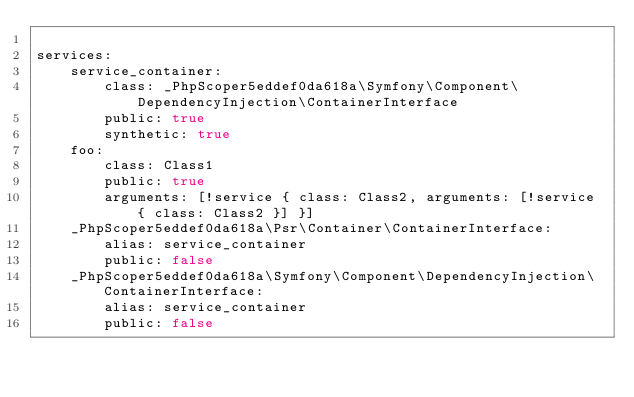Convert code to text. <code><loc_0><loc_0><loc_500><loc_500><_YAML_>
services:
    service_container:
        class: _PhpScoper5eddef0da618a\Symfony\Component\DependencyInjection\ContainerInterface
        public: true
        synthetic: true
    foo:
        class: Class1
        public: true
        arguments: [!service { class: Class2, arguments: [!service { class: Class2 }] }]
    _PhpScoper5eddef0da618a\Psr\Container\ContainerInterface:
        alias: service_container
        public: false
    _PhpScoper5eddef0da618a\Symfony\Component\DependencyInjection\ContainerInterface:
        alias: service_container
        public: false
</code> 